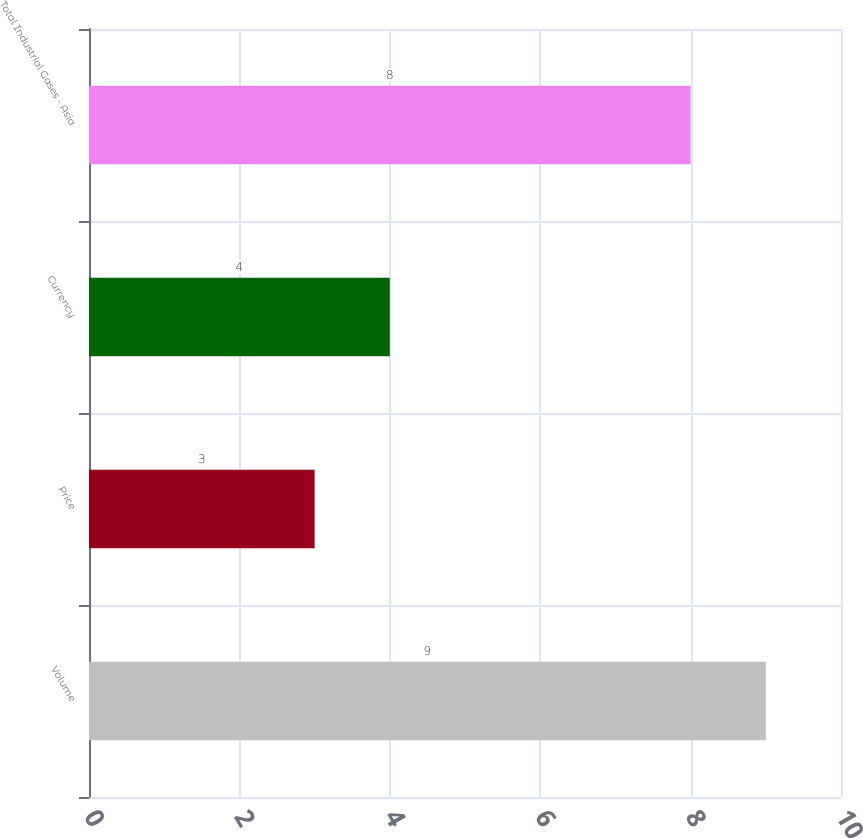Convert chart to OTSL. <chart><loc_0><loc_0><loc_500><loc_500><bar_chart><fcel>Volume<fcel>Price<fcel>Currency<fcel>Total Industrial Gases - Asia<nl><fcel>9<fcel>3<fcel>4<fcel>8<nl></chart> 